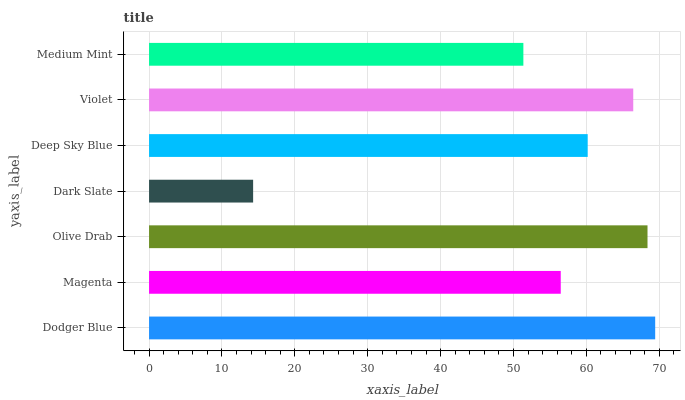Is Dark Slate the minimum?
Answer yes or no. Yes. Is Dodger Blue the maximum?
Answer yes or no. Yes. Is Magenta the minimum?
Answer yes or no. No. Is Magenta the maximum?
Answer yes or no. No. Is Dodger Blue greater than Magenta?
Answer yes or no. Yes. Is Magenta less than Dodger Blue?
Answer yes or no. Yes. Is Magenta greater than Dodger Blue?
Answer yes or no. No. Is Dodger Blue less than Magenta?
Answer yes or no. No. Is Deep Sky Blue the high median?
Answer yes or no. Yes. Is Deep Sky Blue the low median?
Answer yes or no. Yes. Is Violet the high median?
Answer yes or no. No. Is Dodger Blue the low median?
Answer yes or no. No. 